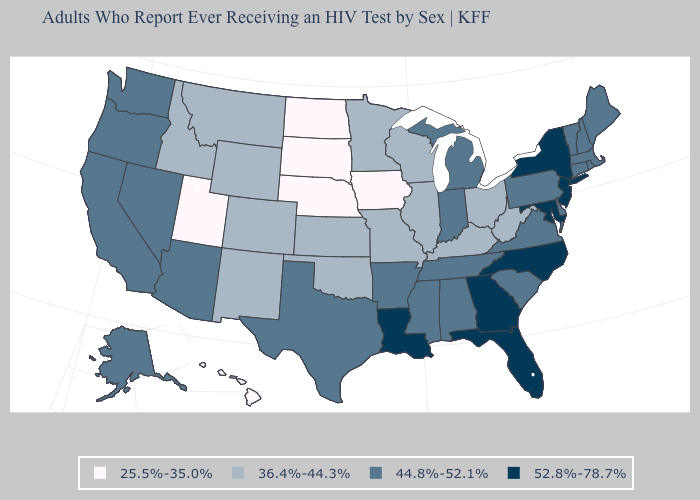Name the states that have a value in the range 25.5%-35.0%?
Give a very brief answer. Hawaii, Iowa, Nebraska, North Dakota, South Dakota, Utah. Among the states that border Vermont , which have the lowest value?
Be succinct. Massachusetts, New Hampshire. Which states have the lowest value in the MidWest?
Give a very brief answer. Iowa, Nebraska, North Dakota, South Dakota. What is the highest value in the West ?
Give a very brief answer. 44.8%-52.1%. Which states hav the highest value in the MidWest?
Give a very brief answer. Indiana, Michigan. What is the highest value in states that border New Hampshire?
Concise answer only. 44.8%-52.1%. Name the states that have a value in the range 36.4%-44.3%?
Write a very short answer. Colorado, Idaho, Illinois, Kansas, Kentucky, Minnesota, Missouri, Montana, New Mexico, Ohio, Oklahoma, West Virginia, Wisconsin, Wyoming. Which states have the highest value in the USA?
Quick response, please. Florida, Georgia, Louisiana, Maryland, New Jersey, New York, North Carolina. Name the states that have a value in the range 36.4%-44.3%?
Give a very brief answer. Colorado, Idaho, Illinois, Kansas, Kentucky, Minnesota, Missouri, Montana, New Mexico, Ohio, Oklahoma, West Virginia, Wisconsin, Wyoming. What is the highest value in the South ?
Short answer required. 52.8%-78.7%. What is the lowest value in states that border Pennsylvania?
Quick response, please. 36.4%-44.3%. Name the states that have a value in the range 44.8%-52.1%?
Write a very short answer. Alabama, Alaska, Arizona, Arkansas, California, Connecticut, Delaware, Indiana, Maine, Massachusetts, Michigan, Mississippi, Nevada, New Hampshire, Oregon, Pennsylvania, Rhode Island, South Carolina, Tennessee, Texas, Vermont, Virginia, Washington. What is the value of Maine?
Concise answer only. 44.8%-52.1%. What is the lowest value in the West?
Be succinct. 25.5%-35.0%. What is the value of Vermont?
Quick response, please. 44.8%-52.1%. 